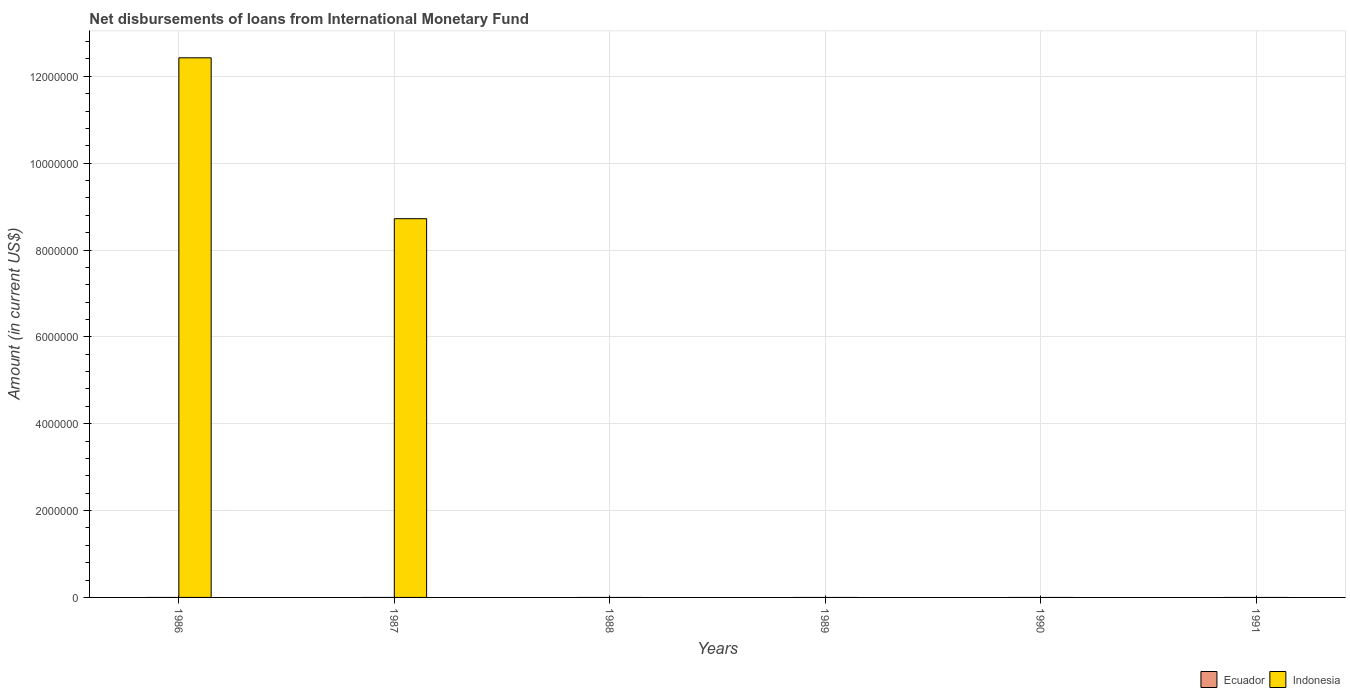Are the number of bars per tick equal to the number of legend labels?
Offer a terse response. No. Are the number of bars on each tick of the X-axis equal?
Offer a very short reply. No. How many bars are there on the 2nd tick from the left?
Your answer should be compact. 1. How many bars are there on the 6th tick from the right?
Give a very brief answer. 1. What is the label of the 5th group of bars from the left?
Offer a very short reply. 1990. In how many cases, is the number of bars for a given year not equal to the number of legend labels?
Ensure brevity in your answer.  6. What is the amount of loans disbursed in Ecuador in 1987?
Offer a very short reply. 0. Across all years, what is the maximum amount of loans disbursed in Indonesia?
Provide a short and direct response. 1.24e+07. Across all years, what is the minimum amount of loans disbursed in Indonesia?
Your response must be concise. 0. What is the total amount of loans disbursed in Indonesia in the graph?
Keep it short and to the point. 2.11e+07. What is the difference between the amount of loans disbursed in Indonesia in 1986 and that in 1987?
Your answer should be very brief. 3.70e+06. What is the average amount of loans disbursed in Indonesia per year?
Give a very brief answer. 3.52e+06. In how many years, is the amount of loans disbursed in Indonesia greater than 10800000 US$?
Make the answer very short. 1. What is the difference between the highest and the lowest amount of loans disbursed in Indonesia?
Make the answer very short. 1.24e+07. Is the sum of the amount of loans disbursed in Indonesia in 1986 and 1987 greater than the maximum amount of loans disbursed in Ecuador across all years?
Offer a terse response. Yes. How many bars are there?
Ensure brevity in your answer.  2. Are all the bars in the graph horizontal?
Offer a terse response. No. How many years are there in the graph?
Keep it short and to the point. 6. What is the difference between two consecutive major ticks on the Y-axis?
Your answer should be very brief. 2.00e+06. Are the values on the major ticks of Y-axis written in scientific E-notation?
Keep it short and to the point. No. Where does the legend appear in the graph?
Your response must be concise. Bottom right. How many legend labels are there?
Your answer should be compact. 2. How are the legend labels stacked?
Give a very brief answer. Horizontal. What is the title of the graph?
Offer a terse response. Net disbursements of loans from International Monetary Fund. Does "Libya" appear as one of the legend labels in the graph?
Keep it short and to the point. No. What is the label or title of the X-axis?
Offer a terse response. Years. What is the Amount (in current US$) in Indonesia in 1986?
Provide a succinct answer. 1.24e+07. What is the Amount (in current US$) of Ecuador in 1987?
Provide a short and direct response. 0. What is the Amount (in current US$) in Indonesia in 1987?
Ensure brevity in your answer.  8.72e+06. What is the Amount (in current US$) in Ecuador in 1988?
Provide a succinct answer. 0. What is the Amount (in current US$) of Indonesia in 1988?
Your response must be concise. 0. What is the Amount (in current US$) of Ecuador in 1990?
Your answer should be very brief. 0. What is the Amount (in current US$) in Ecuador in 1991?
Keep it short and to the point. 0. Across all years, what is the maximum Amount (in current US$) of Indonesia?
Your answer should be very brief. 1.24e+07. What is the total Amount (in current US$) in Indonesia in the graph?
Make the answer very short. 2.11e+07. What is the difference between the Amount (in current US$) in Indonesia in 1986 and that in 1987?
Keep it short and to the point. 3.70e+06. What is the average Amount (in current US$) of Indonesia per year?
Make the answer very short. 3.52e+06. What is the ratio of the Amount (in current US$) of Indonesia in 1986 to that in 1987?
Ensure brevity in your answer.  1.42. What is the difference between the highest and the lowest Amount (in current US$) in Indonesia?
Provide a short and direct response. 1.24e+07. 